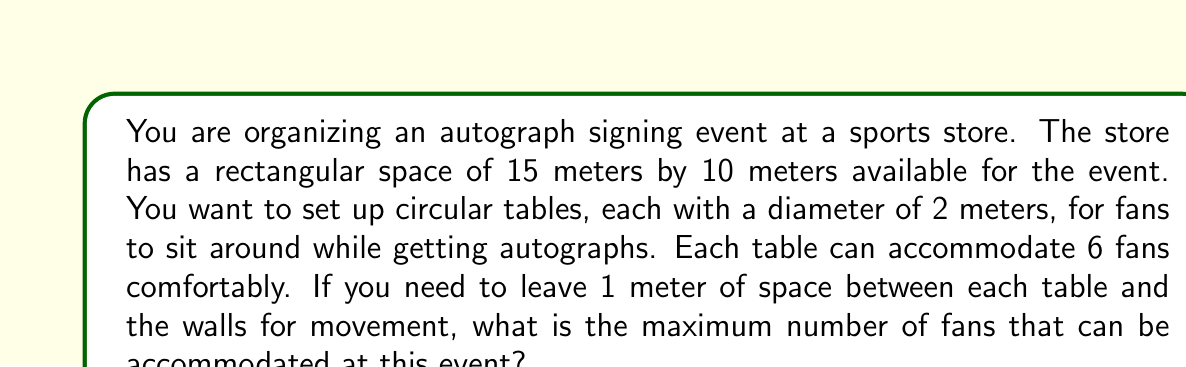Can you answer this question? Let's approach this problem step by step:

1) First, we need to calculate the usable space after accounting for the 1-meter buffer around the edges:
   Usable length = 15 - 2 = 13 meters
   Usable width = 10 - 2 = 8 meters

2) Now, we need to determine how many tables can fit in this space. Each table has a diameter of 2 meters, but we also need to leave space between tables. Let's assume we need a 3-meter center-to-center distance between tables.

3) Number of tables that can fit lengthwise:
   $$\left\lfloor\frac{13}{3}\right\rfloor = 4$$

4) Number of tables that can fit widthwise:
   $$\left\lfloor\frac{8}{3}\right\rfloor = 2$$

5) Total number of tables:
   $$4 \times 2 = 8$$

6) Each table can accommodate 6 fans, so the total number of fans:
   $$8 \times 6 = 48$$

[asy]
unitsize(10mm);
draw((0,0)--(15,0)--(15,10)--(0,10)--cycle);
draw((1,1)--(14,1)--(14,9)--(1,9)--cycle, dashed);
for(int i=0; i<4; ++i) {
  for(int j=0; j<2; ++j) {
    draw(circle((2.5+i*3,2.5+j*3),1));
  }
}
label("15m", (7.5,0), S);
label("10m", (15,5), E);
[/asy]

This diagram illustrates the layout of the tables within the store space.
Answer: The maximum number of fans that can be accommodated at this event is 48. 